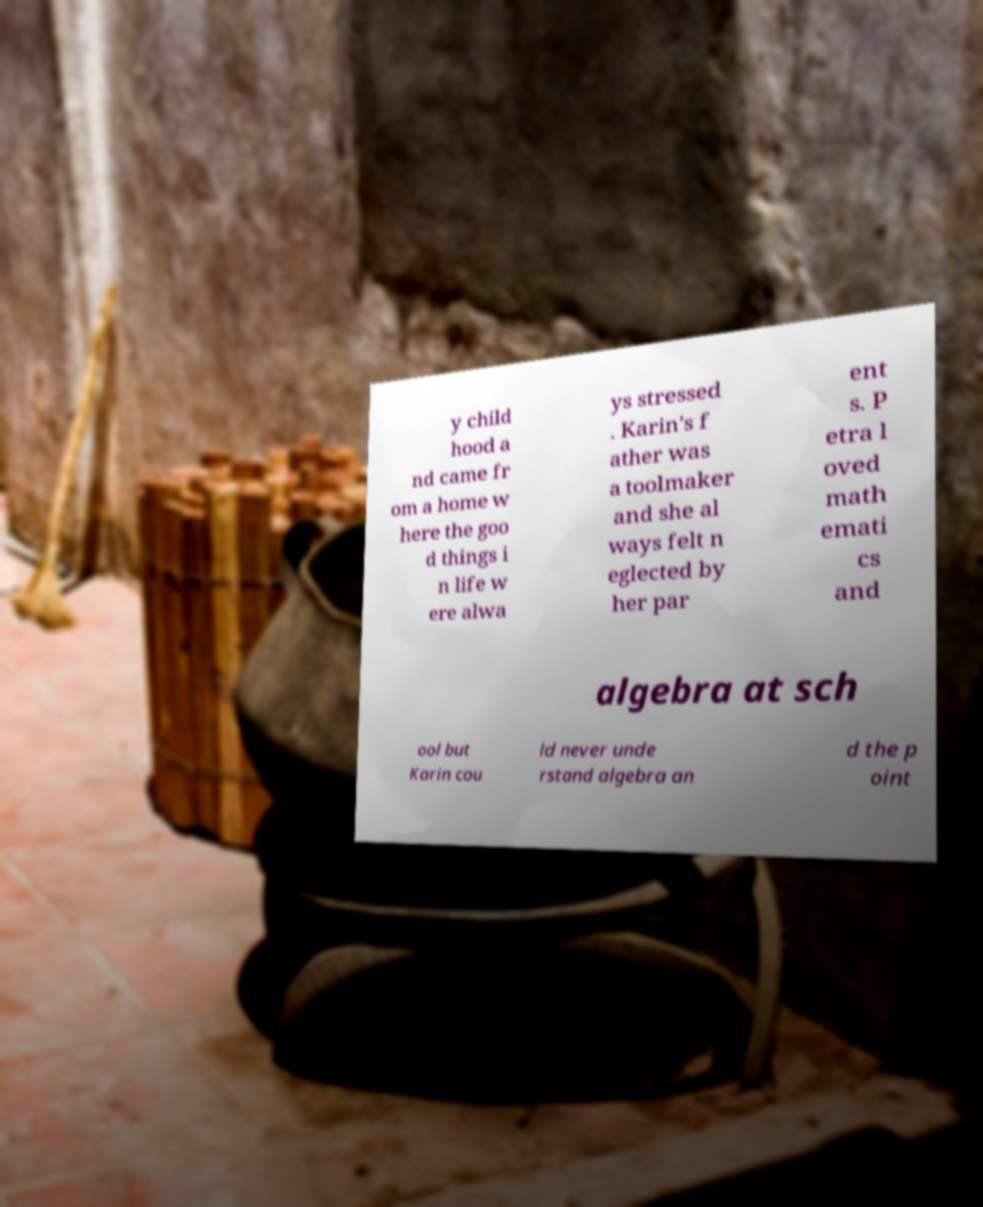Could you assist in decoding the text presented in this image and type it out clearly? y child hood a nd came fr om a home w here the goo d things i n life w ere alwa ys stressed . Karin's f ather was a toolmaker and she al ways felt n eglected by her par ent s. P etra l oved math emati cs and algebra at sch ool but Karin cou ld never unde rstand algebra an d the p oint 